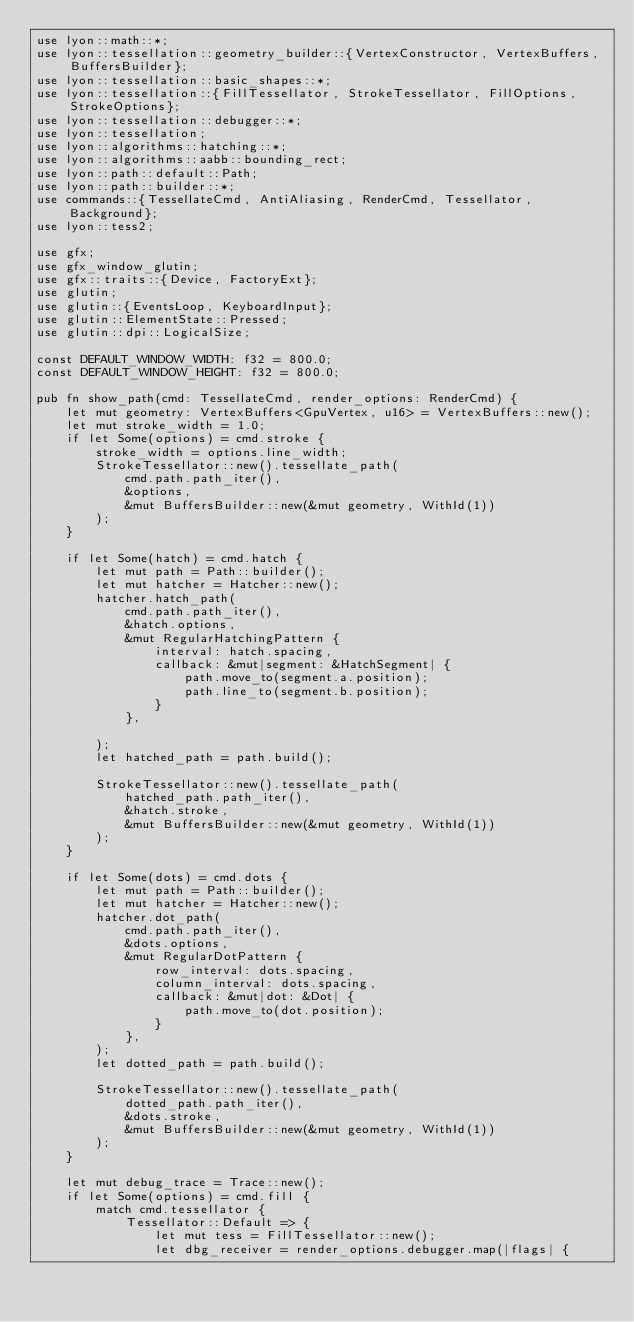Convert code to text. <code><loc_0><loc_0><loc_500><loc_500><_Rust_>use lyon::math::*;
use lyon::tessellation::geometry_builder::{VertexConstructor, VertexBuffers, BuffersBuilder};
use lyon::tessellation::basic_shapes::*;
use lyon::tessellation::{FillTessellator, StrokeTessellator, FillOptions, StrokeOptions};
use lyon::tessellation::debugger::*;
use lyon::tessellation;
use lyon::algorithms::hatching::*;
use lyon::algorithms::aabb::bounding_rect;
use lyon::path::default::Path;
use lyon::path::builder::*;
use commands::{TessellateCmd, AntiAliasing, RenderCmd, Tessellator, Background};
use lyon::tess2;

use gfx;
use gfx_window_glutin;
use gfx::traits::{Device, FactoryExt};
use glutin;
use glutin::{EventsLoop, KeyboardInput};
use glutin::ElementState::Pressed;
use glutin::dpi::LogicalSize;

const DEFAULT_WINDOW_WIDTH: f32 = 800.0;
const DEFAULT_WINDOW_HEIGHT: f32 = 800.0;

pub fn show_path(cmd: TessellateCmd, render_options: RenderCmd) {
    let mut geometry: VertexBuffers<GpuVertex, u16> = VertexBuffers::new();
    let mut stroke_width = 1.0;
    if let Some(options) = cmd.stroke {
        stroke_width = options.line_width;
        StrokeTessellator::new().tessellate_path(
            cmd.path.path_iter(),
            &options,
            &mut BuffersBuilder::new(&mut geometry, WithId(1))
        );
    }

    if let Some(hatch) = cmd.hatch {
        let mut path = Path::builder();
        let mut hatcher = Hatcher::new();
        hatcher.hatch_path(
            cmd.path.path_iter(),
            &hatch.options,
            &mut RegularHatchingPattern {
                interval: hatch.spacing,
                callback: &mut|segment: &HatchSegment| {
                    path.move_to(segment.a.position);
                    path.line_to(segment.b.position);
                }
            },

        );
        let hatched_path = path.build();

        StrokeTessellator::new().tessellate_path(
            hatched_path.path_iter(),
            &hatch.stroke,
            &mut BuffersBuilder::new(&mut geometry, WithId(1))
        );
    }

    if let Some(dots) = cmd.dots {
        let mut path = Path::builder();
        let mut hatcher = Hatcher::new();
        hatcher.dot_path(
            cmd.path.path_iter(),
            &dots.options,
            &mut RegularDotPattern {
                row_interval: dots.spacing,
                column_interval: dots.spacing,
                callback: &mut|dot: &Dot| {
                    path.move_to(dot.position);
                }
            },
        );
        let dotted_path = path.build();

        StrokeTessellator::new().tessellate_path(
            dotted_path.path_iter(),
            &dots.stroke,
            &mut BuffersBuilder::new(&mut geometry, WithId(1))
        );
    }

    let mut debug_trace = Trace::new();
    if let Some(options) = cmd.fill {
        match cmd.tessellator {
            Tessellator::Default => {
                let mut tess = FillTessellator::new();
                let dbg_receiver = render_options.debugger.map(|flags| {</code> 